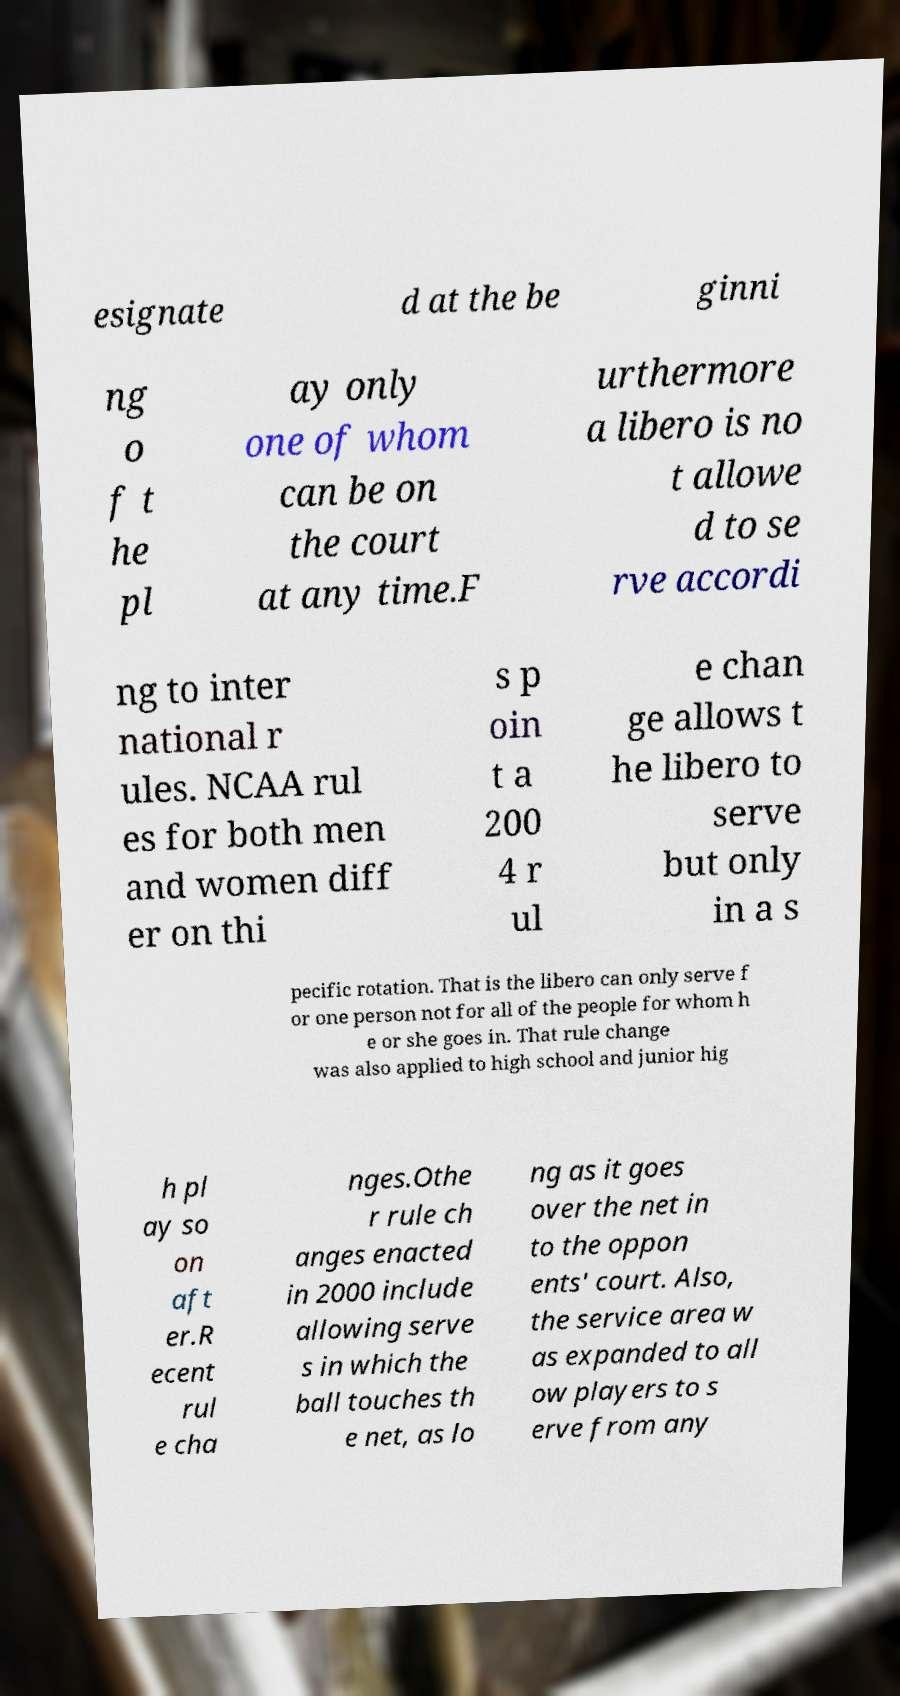Please read and relay the text visible in this image. What does it say? esignate d at the be ginni ng o f t he pl ay only one of whom can be on the court at any time.F urthermore a libero is no t allowe d to se rve accordi ng to inter national r ules. NCAA rul es for both men and women diff er on thi s p oin t a 200 4 r ul e chan ge allows t he libero to serve but only in a s pecific rotation. That is the libero can only serve f or one person not for all of the people for whom h e or she goes in. That rule change was also applied to high school and junior hig h pl ay so on aft er.R ecent rul e cha nges.Othe r rule ch anges enacted in 2000 include allowing serve s in which the ball touches th e net, as lo ng as it goes over the net in to the oppon ents' court. Also, the service area w as expanded to all ow players to s erve from any 